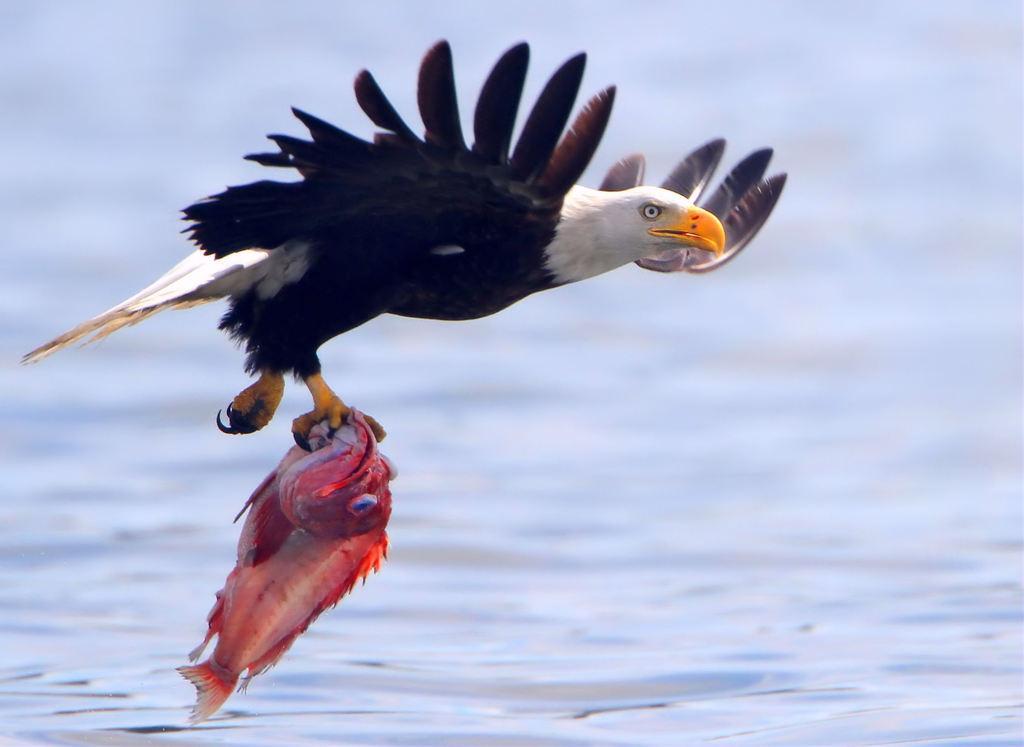How would you summarize this image in a sentence or two? In this image in the center there is a bird holding food and the background is blurry. 